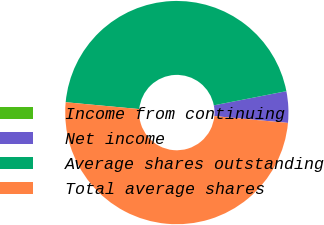<chart> <loc_0><loc_0><loc_500><loc_500><pie_chart><fcel>Income from continuing<fcel>Net income<fcel>Average shares outstanding<fcel>Total average shares<nl><fcel>0.0%<fcel>4.55%<fcel>45.45%<fcel>50.0%<nl></chart> 